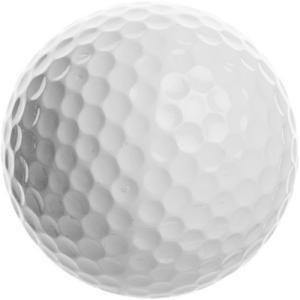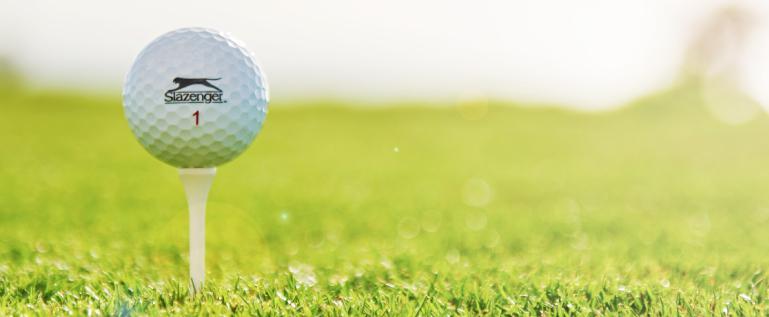The first image is the image on the left, the second image is the image on the right. Examine the images to the left and right. Is the description "In one image, all golf balls are on a tee, and in the other image, no golf balls are on a tee." accurate? Answer yes or no. Yes. The first image is the image on the left, the second image is the image on the right. Assess this claim about the two images: "The right image contains no less than two golf balls.". Correct or not? Answer yes or no. No. 